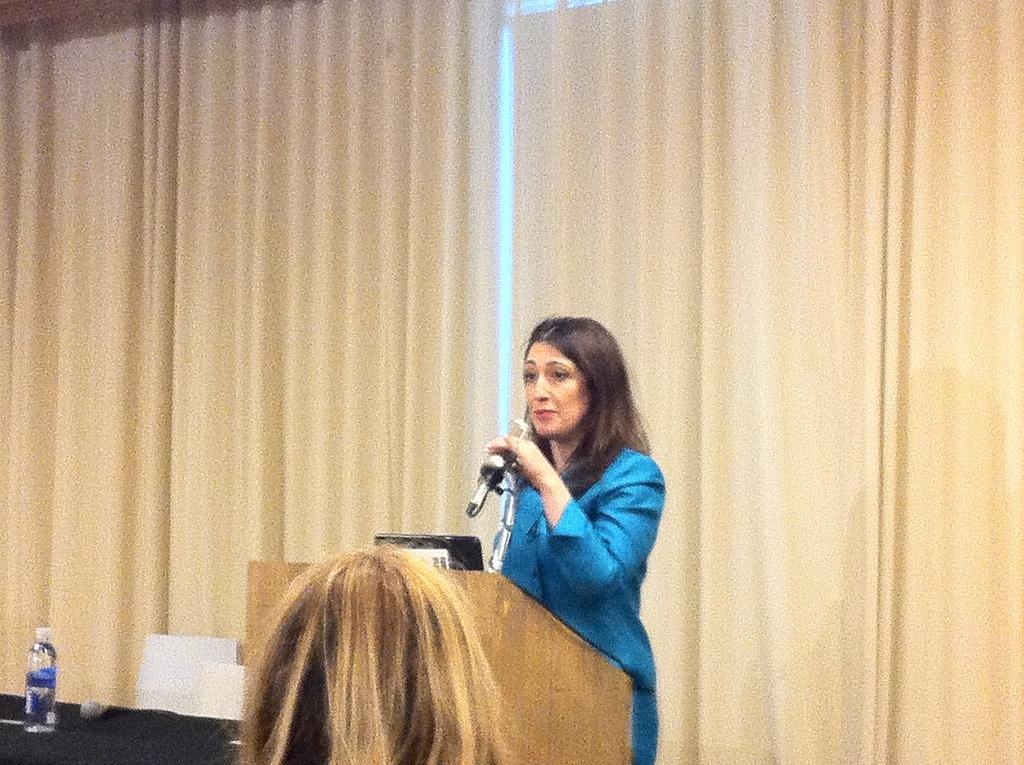In one or two sentences, can you explain what this image depicts? In this image I can see a woman is holding mic and wearing blue color dress. She is standing in front of podium. We can see laptop on it. I can see water bottle and cream color curtain. 